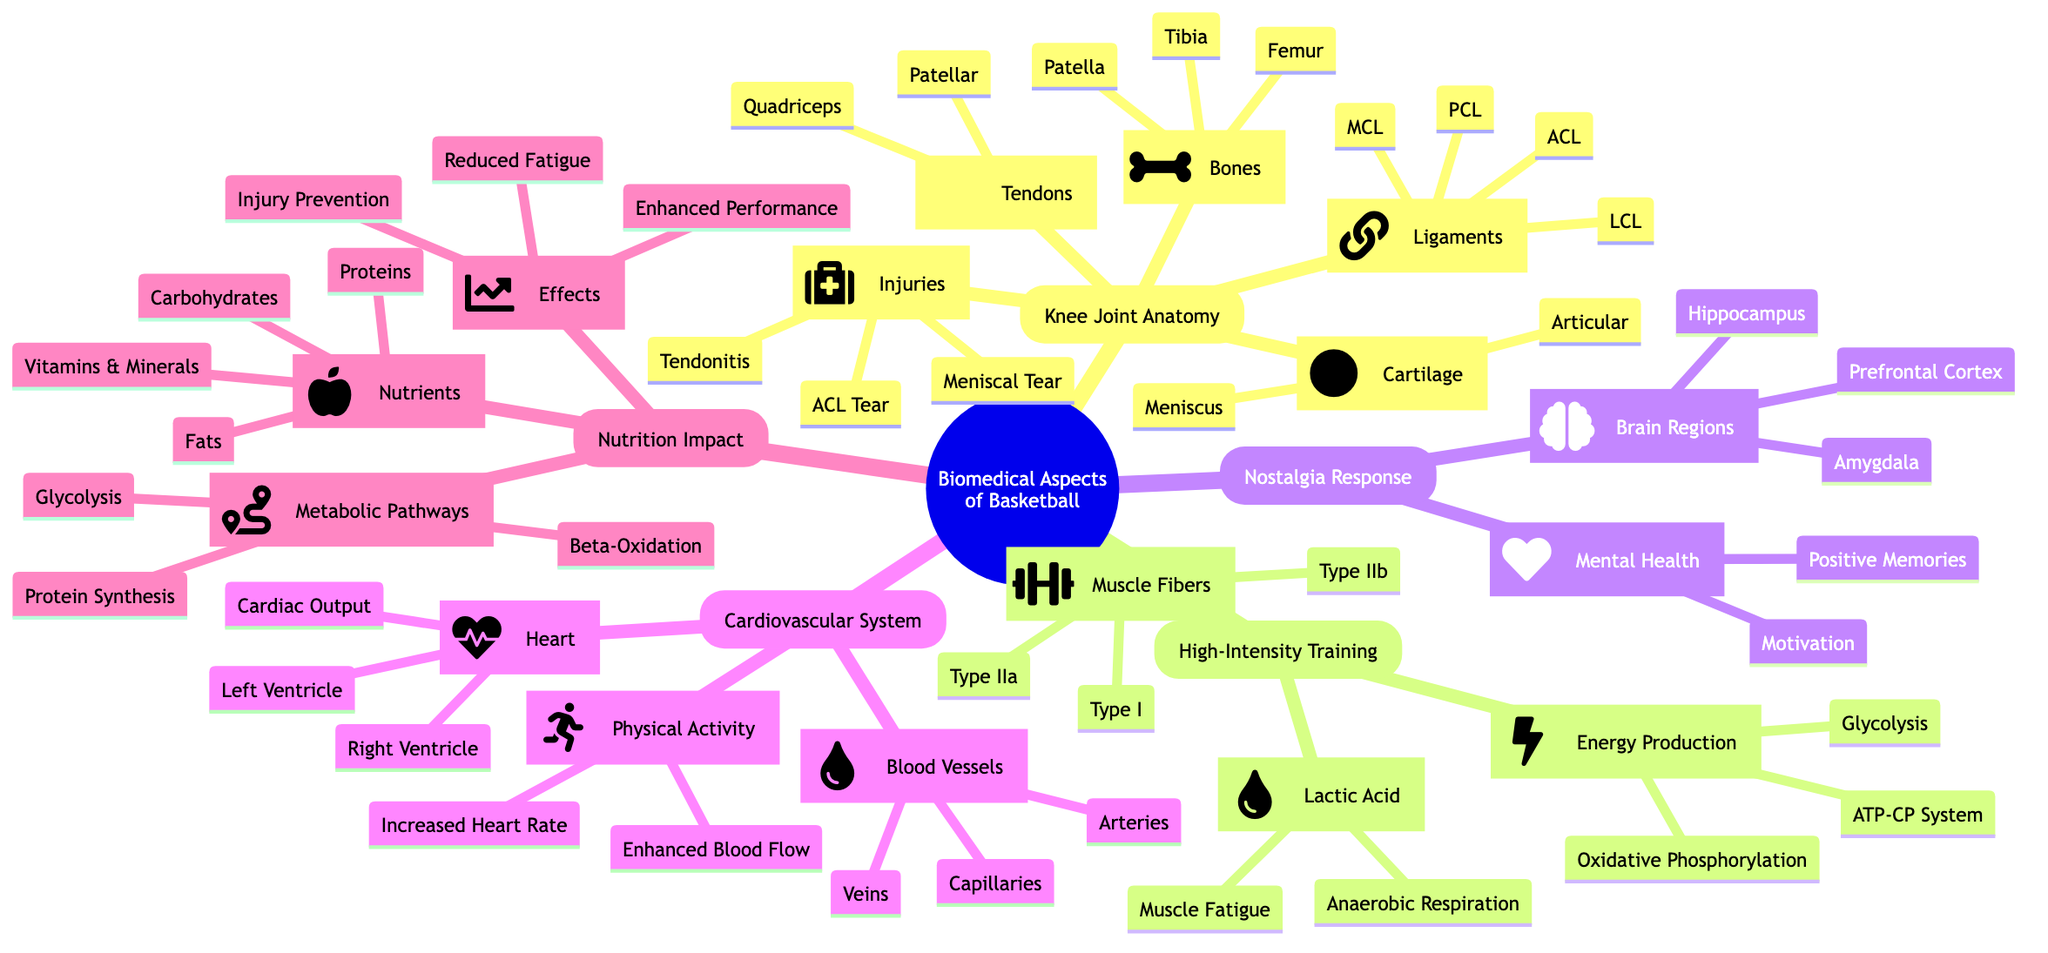What are the two main ligaments identified in the knee joint anatomy? The knee joint anatomy part lists four ligaments under 'Ligaments,' among which ACL and PCL are two significant ligaments.
Answer: ACL, PCL How many types of muscle fibers are categorized in the high-intensity training section? The high-intensity training section contains a node labeled 'Muscle Fibers' with three distinct types listed: Type I, Type IIa, and Type IIb. This indicates there are three types of muscle fibers.
Answer: 3 Which brain region is associated with positive memories in the nostalgia response? In the nostalgia response section, the 'Mental Health' node lists 'Positive Memories' under its branch, showing it correlates with specific brain regions like the Hippocampus and Amygdala.
Answer: Hippocampus What nutrient type is illustrated under the nutrition impact section? Under the nutrition impact section, the 'Nutrients' node clearly outlines four types, including Carbohydrates, Proteins, Fats, and Vitamins & Minerals, indicating that a variety of nutrient types are represented.
Answer: Carbohydrates Which injury is classified under the knee joint anatomy? The diagram highlights several injuries under 'Injuries' in the knee joint anatomy section, including ACL Tear, Meniscal Tear, and Tendonitis. Thus, ACL Tear is one of the specific injuries mentioned.
Answer: ACL Tear How does intense physical activity influence heart rate according to the cardiovascular system section? The cardiovascular system section mentions increased heart rate explicitly under 'Physical Activity,' indicating the direct effect of exercise on the heart rate. Hence, it shows that physical activity elevates heart rate.
Answer: Increased Heart Rate What is the primary energy production process during high-intensity training? Examining the high-intensity training section, 'Energy Production' outlines three processes, with Glycolysis being a central and typical method when high-intensity efforts are applied, leading to its identification as a primary process.
Answer: Glycolysis What is the impact of nutrition on athletic performance as noted in the diagram? Within the nutrition impact section, the 'Effects' node indicates several consequences of proper nutrition, including Enhanced Performance. This reveals a direct connection between nutrition and improved sports performance.
Answer: Enhanced Performance Which types of cartilage are mentioned in the anatomy of a basketball player's knee joint? The cartilage classification under knee joint anatomy lists 'Meniscus' and 'Articular' explicitly, indicating the types of cartilage associated with this anatomical area.
Answer: Meniscus, Articular 